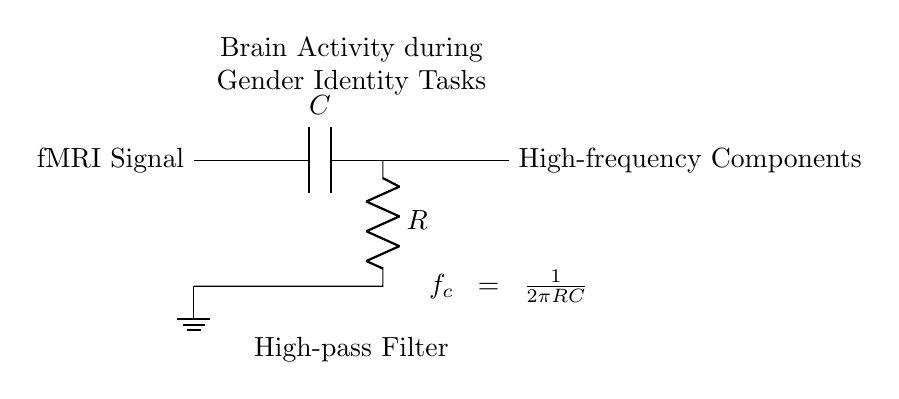What is the input signal of this circuit? The input signal is labeled as "fMRI Signal," which indicates the data being fed into the circuit for processing.
Answer: fMRI Signal What does the capacitor represent in this high-pass filter? The capacitor, denoted as "C," is a key component that blocks low-frequency signals while allowing high-frequency signals to pass through, compliant with the filter's function.
Answer: C What is the function of the resistor in this circuit? The resistor, labeled "R," works in conjunction with the capacitor to set the cutoff frequency for the high-pass filter, thus determining which frequency components are allowed to pass.
Answer: R What is the output of this high-pass filter? The output is labeled as "High-frequency Components," which refers to the part of the signal that remains after low-frequency components have been filtered out.
Answer: High-frequency Components What is the cutoff frequency equation in this filter circuit? The equation provided in the circuit diagram is f_c = 1/(2πRC), representing how the cutoff frequency is determined by the resistor and capacitor values.
Answer: f_c = 1/(2πRC) What effect does increasing the capacitance have on the cutoff frequency? Increasing the capacitance will decrease the cutoff frequency according to the equation, leading to more low-frequency components being filtered out, thus allowing lower frequencies to pass through the filter.
Answer: Decrease cutoff frequency What type of filter is this circuit classified as? This circuit is a high-pass filter, as it is designed to allow high-frequency signals to pass while attenuating low-frequency signals.
Answer: High-pass filter 